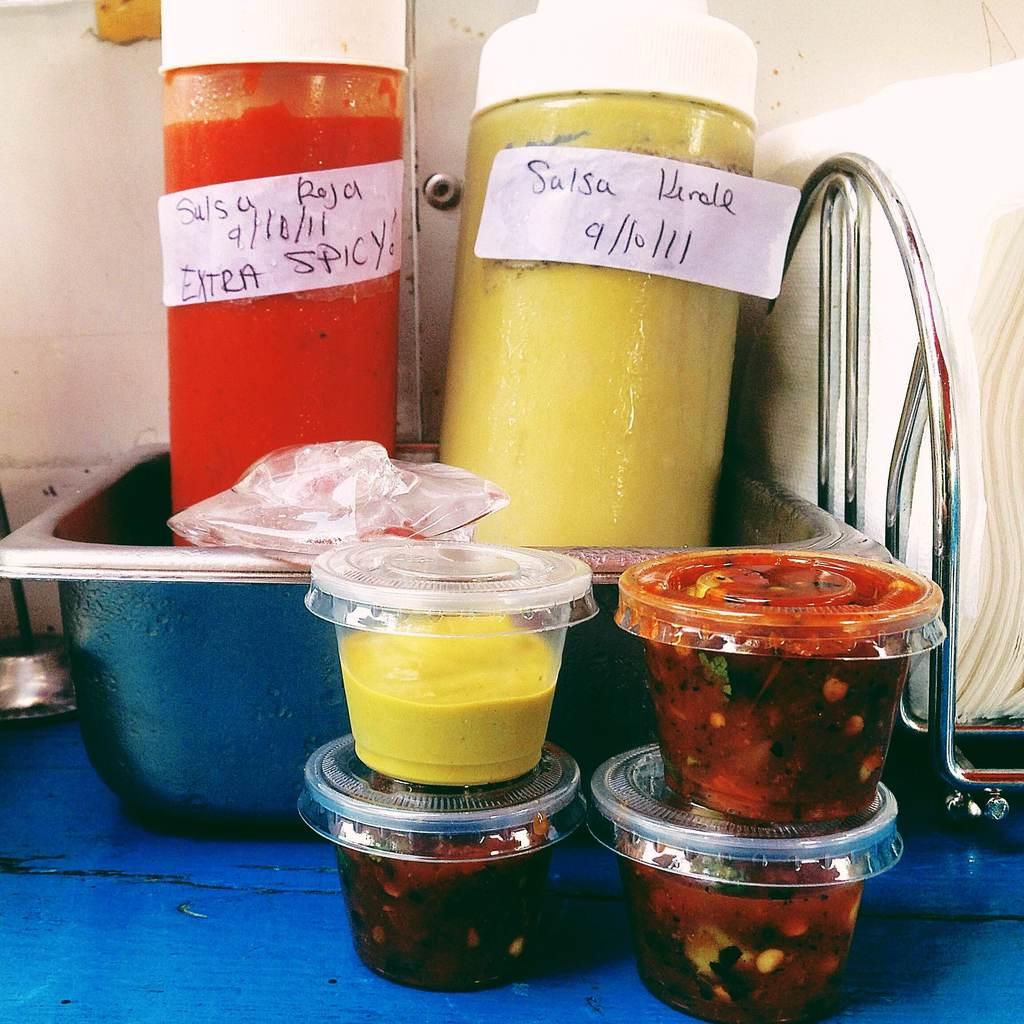How many cups are visible in the image? There are four cups in the image. What is inside the cups? The cups contain preservative food. What else can be seen on the table besides the cups? There is a container in the image, which holds two bottles with different sauces. Are there any cherries on the table in the image? There is no mention of cherries in the provided facts, so we cannot determine if they are present in the image. Can you see a balloon floating above the table in the image? There is no mention of a balloon in the provided facts, so we cannot determine if it is present in the image. 